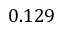Convert formula to latex. <formula><loc_0><loc_0><loc_500><loc_500>0 . 1 2 9</formula> 